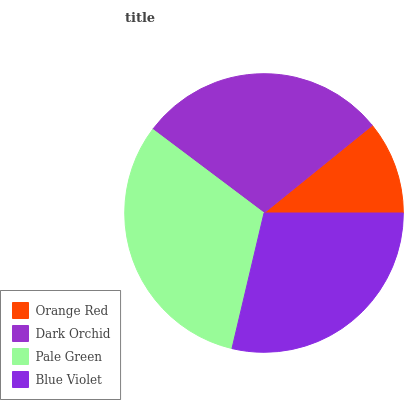Is Orange Red the minimum?
Answer yes or no. Yes. Is Pale Green the maximum?
Answer yes or no. Yes. Is Dark Orchid the minimum?
Answer yes or no. No. Is Dark Orchid the maximum?
Answer yes or no. No. Is Dark Orchid greater than Orange Red?
Answer yes or no. Yes. Is Orange Red less than Dark Orchid?
Answer yes or no. Yes. Is Orange Red greater than Dark Orchid?
Answer yes or no. No. Is Dark Orchid less than Orange Red?
Answer yes or no. No. Is Dark Orchid the high median?
Answer yes or no. Yes. Is Blue Violet the low median?
Answer yes or no. Yes. Is Blue Violet the high median?
Answer yes or no. No. Is Orange Red the low median?
Answer yes or no. No. 